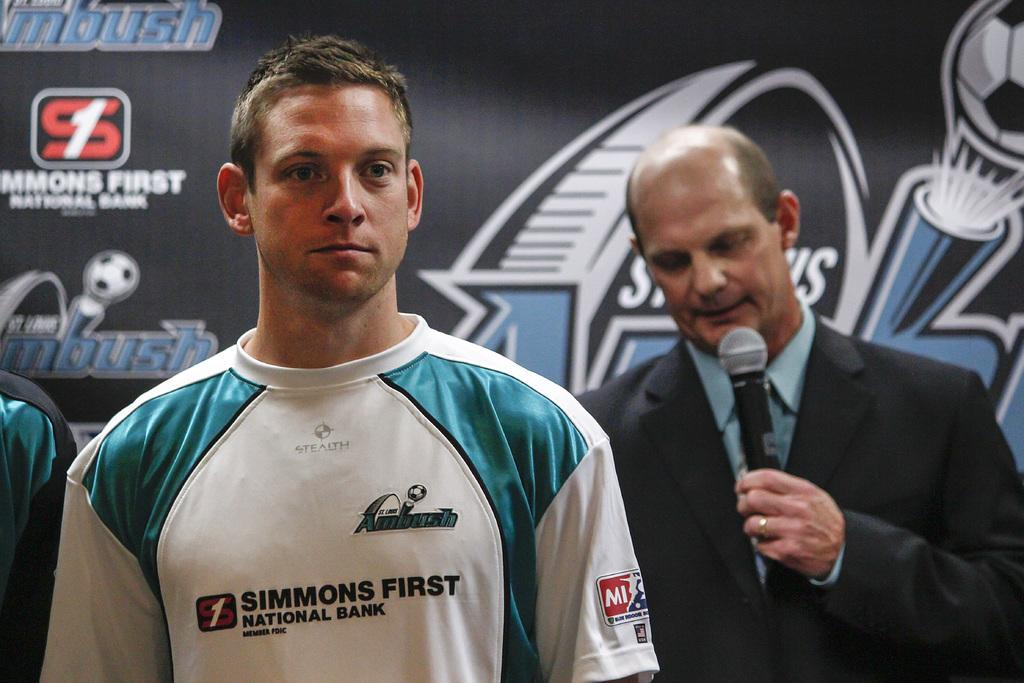Provide a one-sentence caption for the provided image. Man wearing a shirt that says Simmons First in front of a man holding a mic. 